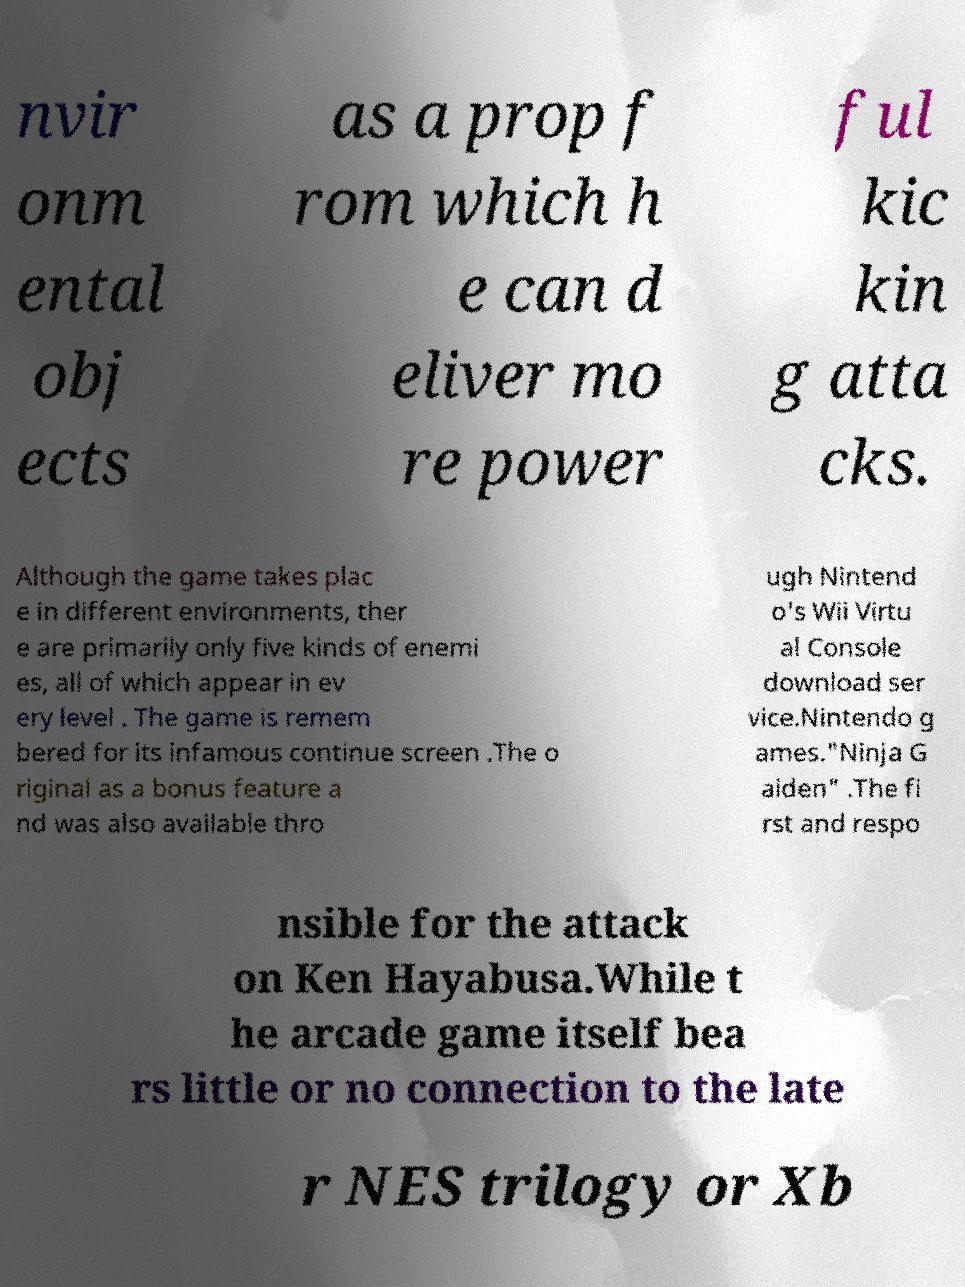Could you assist in decoding the text presented in this image and type it out clearly? nvir onm ental obj ects as a prop f rom which h e can d eliver mo re power ful kic kin g atta cks. Although the game takes plac e in different environments, ther e are primarily only five kinds of enemi es, all of which appear in ev ery level . The game is remem bered for its infamous continue screen .The o riginal as a bonus feature a nd was also available thro ugh Nintend o's Wii Virtu al Console download ser vice.Nintendo g ames."Ninja G aiden" .The fi rst and respo nsible for the attack on Ken Hayabusa.While t he arcade game itself bea rs little or no connection to the late r NES trilogy or Xb 